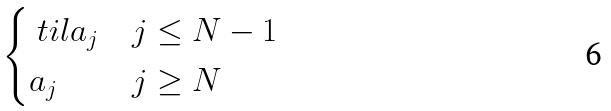<formula> <loc_0><loc_0><loc_500><loc_500>\begin{cases} \ t i l a _ { j } & j \leq N - 1 \\ a _ { j } & j \geq N \end{cases}</formula> 